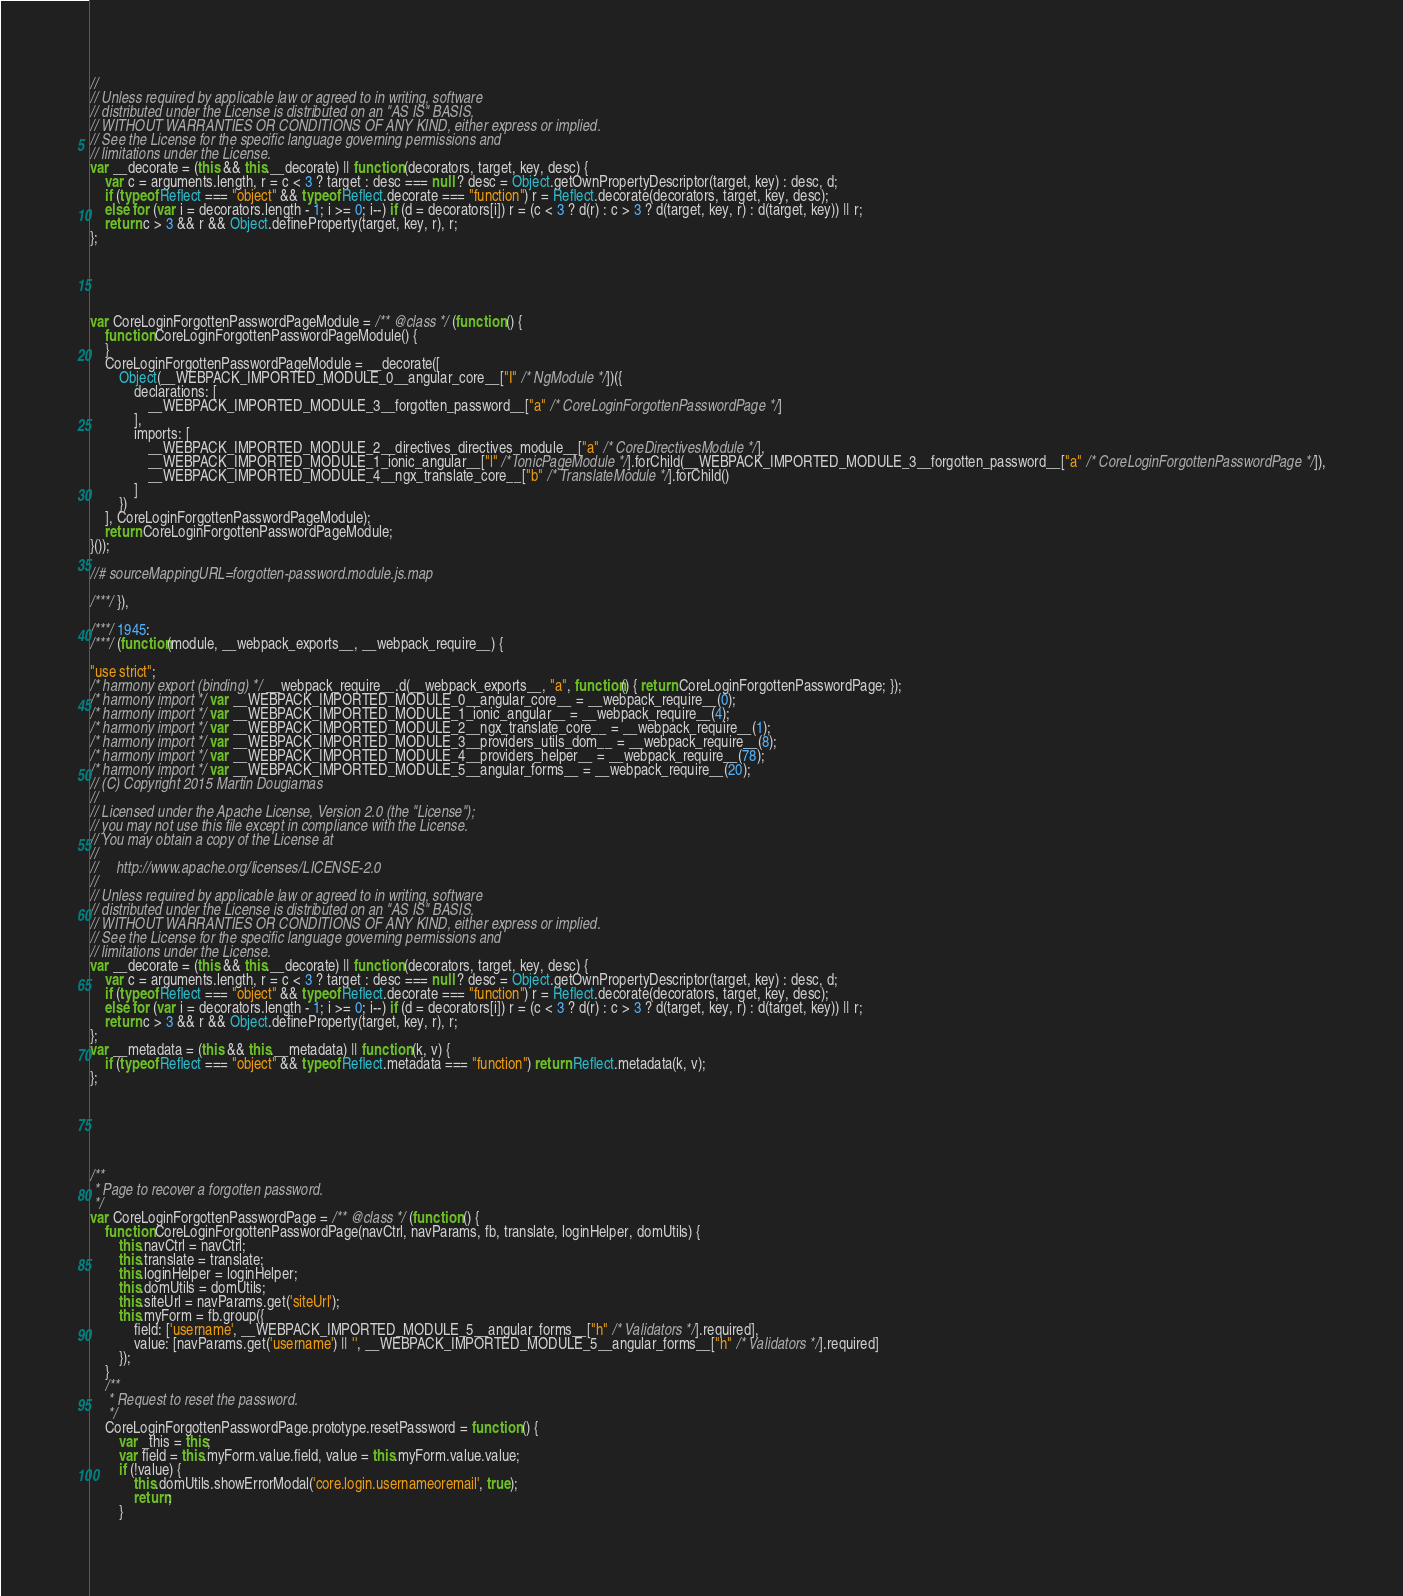<code> <loc_0><loc_0><loc_500><loc_500><_JavaScript_>//
// Unless required by applicable law or agreed to in writing, software
// distributed under the License is distributed on an "AS IS" BASIS,
// WITHOUT WARRANTIES OR CONDITIONS OF ANY KIND, either express or implied.
// See the License for the specific language governing permissions and
// limitations under the License.
var __decorate = (this && this.__decorate) || function (decorators, target, key, desc) {
    var c = arguments.length, r = c < 3 ? target : desc === null ? desc = Object.getOwnPropertyDescriptor(target, key) : desc, d;
    if (typeof Reflect === "object" && typeof Reflect.decorate === "function") r = Reflect.decorate(decorators, target, key, desc);
    else for (var i = decorators.length - 1; i >= 0; i--) if (d = decorators[i]) r = (c < 3 ? d(r) : c > 3 ? d(target, key, r) : d(target, key)) || r;
    return c > 3 && r && Object.defineProperty(target, key, r), r;
};





var CoreLoginForgottenPasswordPageModule = /** @class */ (function () {
    function CoreLoginForgottenPasswordPageModule() {
    }
    CoreLoginForgottenPasswordPageModule = __decorate([
        Object(__WEBPACK_IMPORTED_MODULE_0__angular_core__["I" /* NgModule */])({
            declarations: [
                __WEBPACK_IMPORTED_MODULE_3__forgotten_password__["a" /* CoreLoginForgottenPasswordPage */]
            ],
            imports: [
                __WEBPACK_IMPORTED_MODULE_2__directives_directives_module__["a" /* CoreDirectivesModule */],
                __WEBPACK_IMPORTED_MODULE_1_ionic_angular__["l" /* IonicPageModule */].forChild(__WEBPACK_IMPORTED_MODULE_3__forgotten_password__["a" /* CoreLoginForgottenPasswordPage */]),
                __WEBPACK_IMPORTED_MODULE_4__ngx_translate_core__["b" /* TranslateModule */].forChild()
            ]
        })
    ], CoreLoginForgottenPasswordPageModule);
    return CoreLoginForgottenPasswordPageModule;
}());

//# sourceMappingURL=forgotten-password.module.js.map

/***/ }),

/***/ 1945:
/***/ (function(module, __webpack_exports__, __webpack_require__) {

"use strict";
/* harmony export (binding) */ __webpack_require__.d(__webpack_exports__, "a", function() { return CoreLoginForgottenPasswordPage; });
/* harmony import */ var __WEBPACK_IMPORTED_MODULE_0__angular_core__ = __webpack_require__(0);
/* harmony import */ var __WEBPACK_IMPORTED_MODULE_1_ionic_angular__ = __webpack_require__(4);
/* harmony import */ var __WEBPACK_IMPORTED_MODULE_2__ngx_translate_core__ = __webpack_require__(1);
/* harmony import */ var __WEBPACK_IMPORTED_MODULE_3__providers_utils_dom__ = __webpack_require__(8);
/* harmony import */ var __WEBPACK_IMPORTED_MODULE_4__providers_helper__ = __webpack_require__(78);
/* harmony import */ var __WEBPACK_IMPORTED_MODULE_5__angular_forms__ = __webpack_require__(20);
// (C) Copyright 2015 Martin Dougiamas
//
// Licensed under the Apache License, Version 2.0 (the "License");
// you may not use this file except in compliance with the License.
// You may obtain a copy of the License at
//
//     http://www.apache.org/licenses/LICENSE-2.0
//
// Unless required by applicable law or agreed to in writing, software
// distributed under the License is distributed on an "AS IS" BASIS,
// WITHOUT WARRANTIES OR CONDITIONS OF ANY KIND, either express or implied.
// See the License for the specific language governing permissions and
// limitations under the License.
var __decorate = (this && this.__decorate) || function (decorators, target, key, desc) {
    var c = arguments.length, r = c < 3 ? target : desc === null ? desc = Object.getOwnPropertyDescriptor(target, key) : desc, d;
    if (typeof Reflect === "object" && typeof Reflect.decorate === "function") r = Reflect.decorate(decorators, target, key, desc);
    else for (var i = decorators.length - 1; i >= 0; i--) if (d = decorators[i]) r = (c < 3 ? d(r) : c > 3 ? d(target, key, r) : d(target, key)) || r;
    return c > 3 && r && Object.defineProperty(target, key, r), r;
};
var __metadata = (this && this.__metadata) || function (k, v) {
    if (typeof Reflect === "object" && typeof Reflect.metadata === "function") return Reflect.metadata(k, v);
};






/**
 * Page to recover a forgotten password.
 */
var CoreLoginForgottenPasswordPage = /** @class */ (function () {
    function CoreLoginForgottenPasswordPage(navCtrl, navParams, fb, translate, loginHelper, domUtils) {
        this.navCtrl = navCtrl;
        this.translate = translate;
        this.loginHelper = loginHelper;
        this.domUtils = domUtils;
        this.siteUrl = navParams.get('siteUrl');
        this.myForm = fb.group({
            field: ['username', __WEBPACK_IMPORTED_MODULE_5__angular_forms__["h" /* Validators */].required],
            value: [navParams.get('username') || '', __WEBPACK_IMPORTED_MODULE_5__angular_forms__["h" /* Validators */].required]
        });
    }
    /**
     * Request to reset the password.
     */
    CoreLoginForgottenPasswordPage.prototype.resetPassword = function () {
        var _this = this;
        var field = this.myForm.value.field, value = this.myForm.value.value;
        if (!value) {
            this.domUtils.showErrorModal('core.login.usernameoremail', true);
            return;
        }</code> 